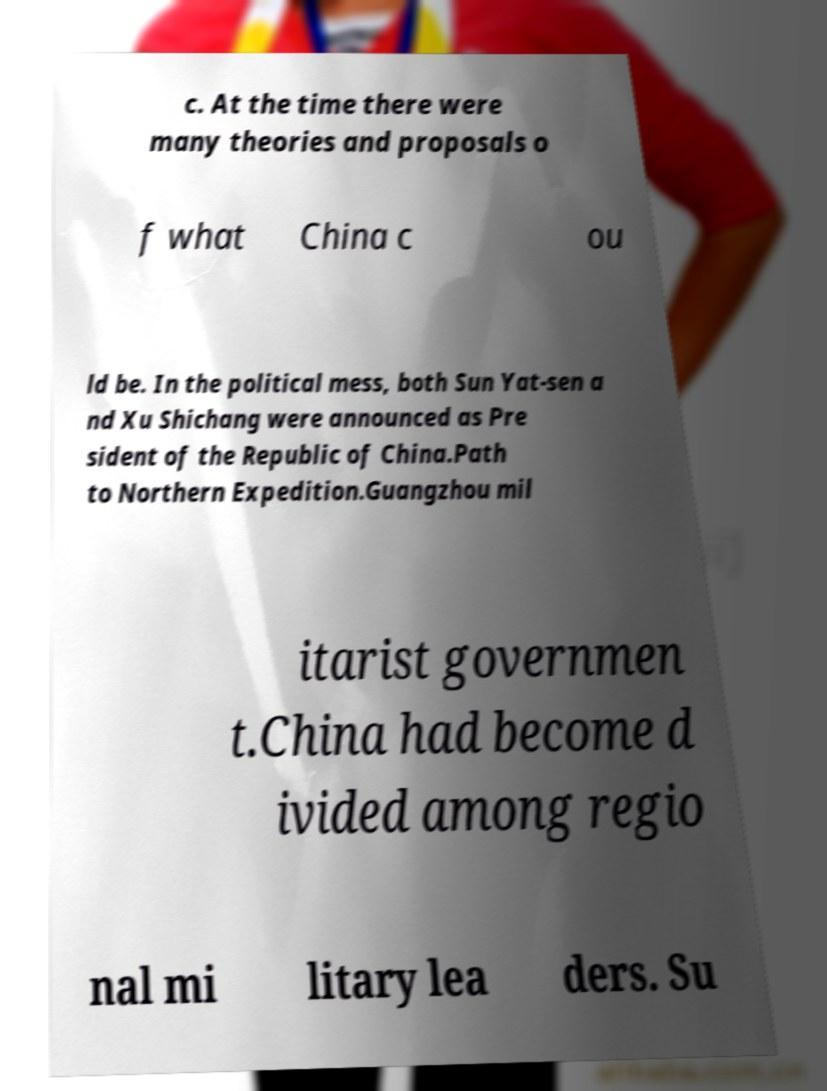Please identify and transcribe the text found in this image. c. At the time there were many theories and proposals o f what China c ou ld be. In the political mess, both Sun Yat-sen a nd Xu Shichang were announced as Pre sident of the Republic of China.Path to Northern Expedition.Guangzhou mil itarist governmen t.China had become d ivided among regio nal mi litary lea ders. Su 